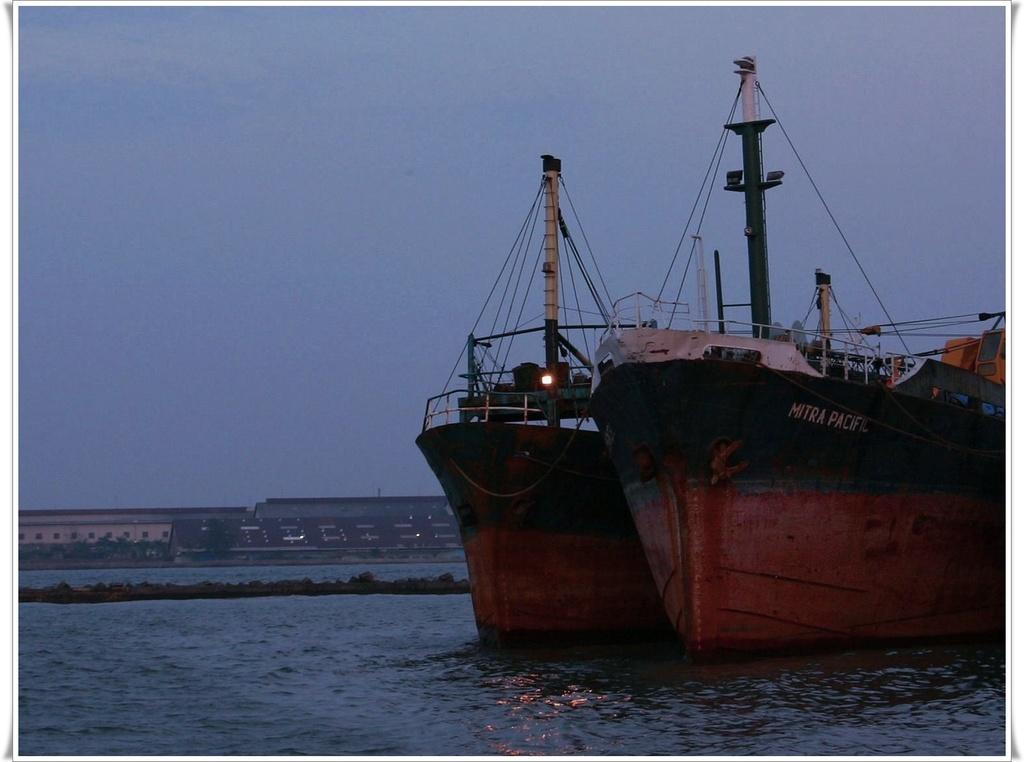How many ships can be seen in the image? There are two ships in the image. Where are the ships located? The ships are on the water. What can be seen in the background of the image? There are buildings, trees, and the sky visible in the background of the image. Are there any dinosaurs visible in the image? No, there are no dinosaurs present in the image. 